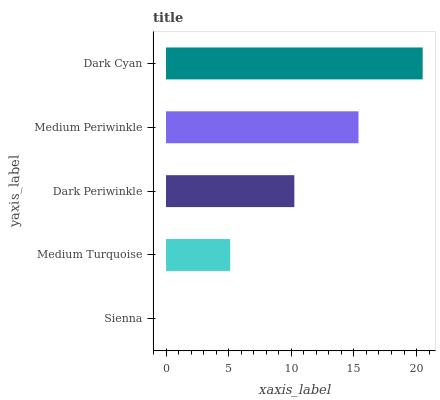Is Sienna the minimum?
Answer yes or no. Yes. Is Dark Cyan the maximum?
Answer yes or no. Yes. Is Medium Turquoise the minimum?
Answer yes or no. No. Is Medium Turquoise the maximum?
Answer yes or no. No. Is Medium Turquoise greater than Sienna?
Answer yes or no. Yes. Is Sienna less than Medium Turquoise?
Answer yes or no. Yes. Is Sienna greater than Medium Turquoise?
Answer yes or no. No. Is Medium Turquoise less than Sienna?
Answer yes or no. No. Is Dark Periwinkle the high median?
Answer yes or no. Yes. Is Dark Periwinkle the low median?
Answer yes or no. Yes. Is Medium Turquoise the high median?
Answer yes or no. No. Is Medium Periwinkle the low median?
Answer yes or no. No. 